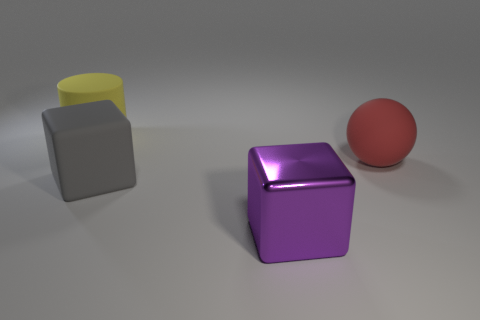Add 4 big gray matte blocks. How many objects exist? 8 Subtract all balls. How many objects are left? 3 Add 1 big metal blocks. How many big metal blocks exist? 2 Subtract 0 purple balls. How many objects are left? 4 Subtract all green metallic objects. Subtract all metallic blocks. How many objects are left? 3 Add 3 metallic objects. How many metallic objects are left? 4 